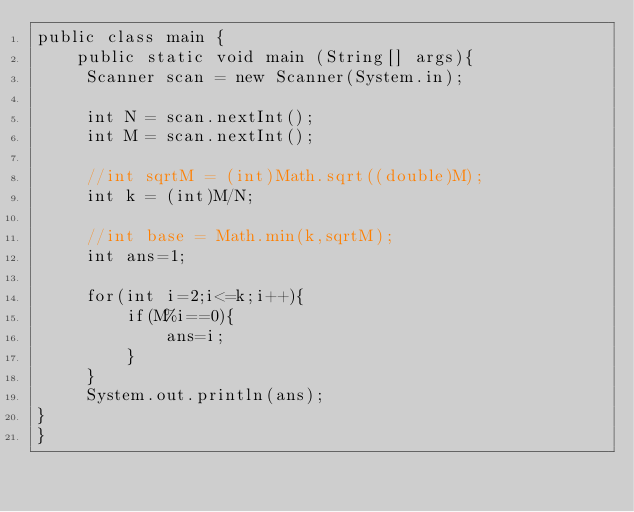<code> <loc_0><loc_0><loc_500><loc_500><_Java_>public class main {
	public static void main (String[] args){
     Scanner scan = new Scanner(System.in);
     
     int N = scan.nextInt();
     int M = scan.nextInt();
     
     //int sqrtM = (int)Math.sqrt((double)M);
     int k = (int)M/N;
     
     //int base = Math.min(k,sqrtM);
     int ans=1;
     
     for(int i=2;i<=k;i++){
    	 if(M%i==0){
    		 ans=i;
    	 }
     }	 
     System.out.println(ans);
}
}
</code> 